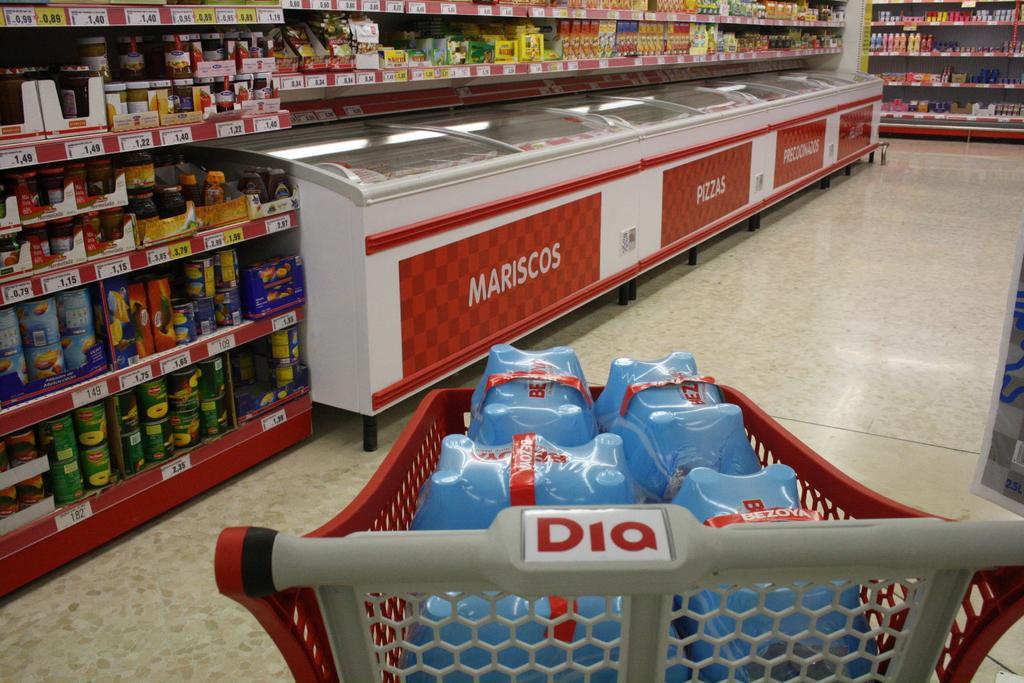<image>
Summarize the visual content of the image. A supermarket shopper heads toward freezer cases containing mariscos and pizzas. 